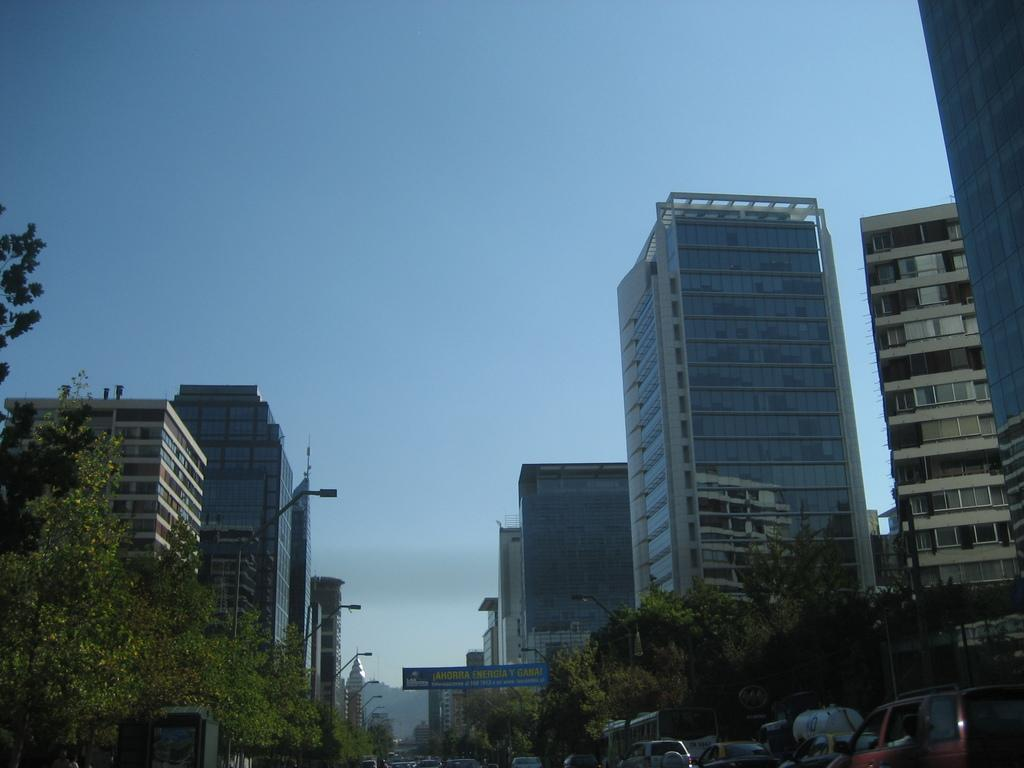What type of structures can be seen in the image? There are buildings in the image. What natural elements are present in the image? There are trees in the image. Are there any additional decorative elements in the image? Yes, there are banners in the image. Can you tell me how many kittens are sitting on the minister's donkey in the image? There are no kittens or ministers present in the image, nor is there a donkey. 